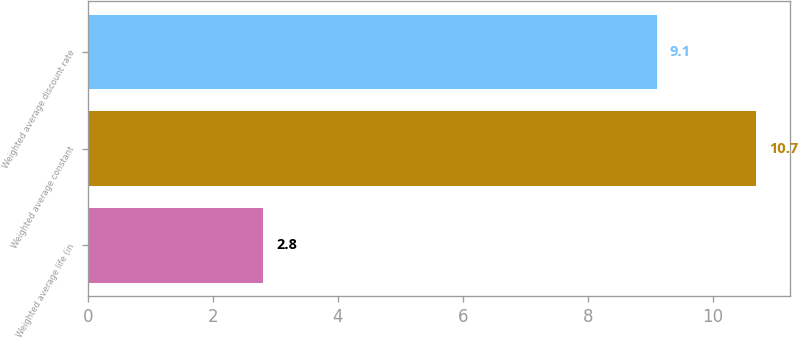<chart> <loc_0><loc_0><loc_500><loc_500><bar_chart><fcel>Weighted average life (in<fcel>Weighted average constant<fcel>Weighted average discount rate<nl><fcel>2.8<fcel>10.7<fcel>9.1<nl></chart> 